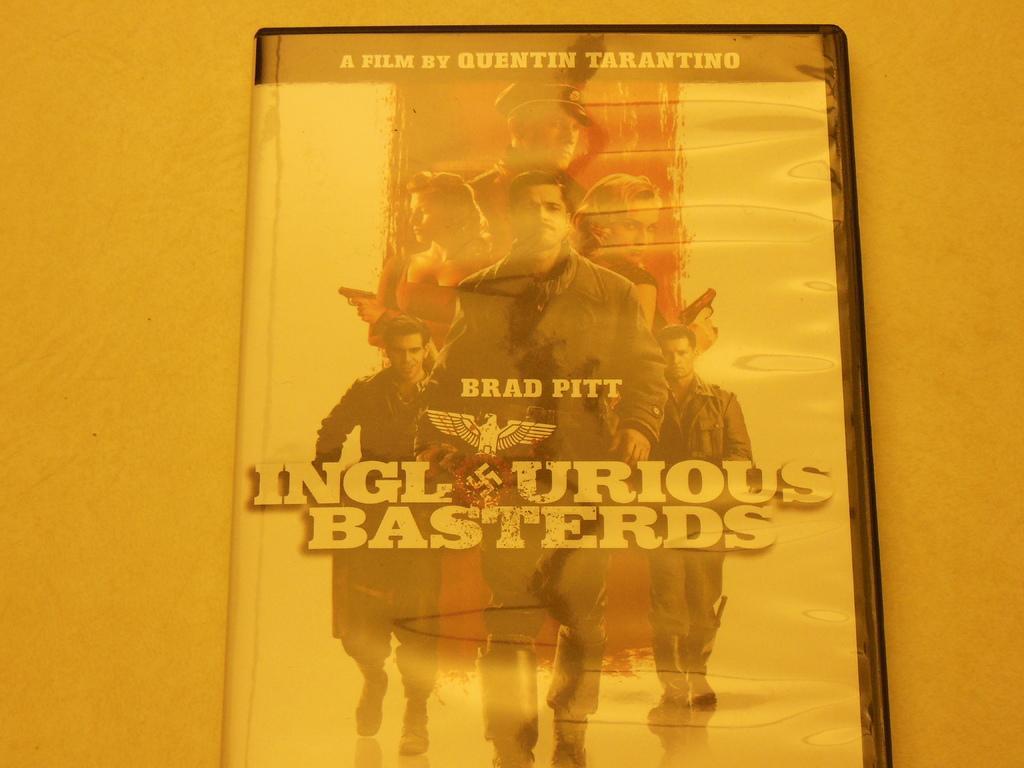In one or two sentences, can you explain what this image depicts? In the picture,there is a CD and on the CD cover,the name of the film and the casting pictures were printed. 